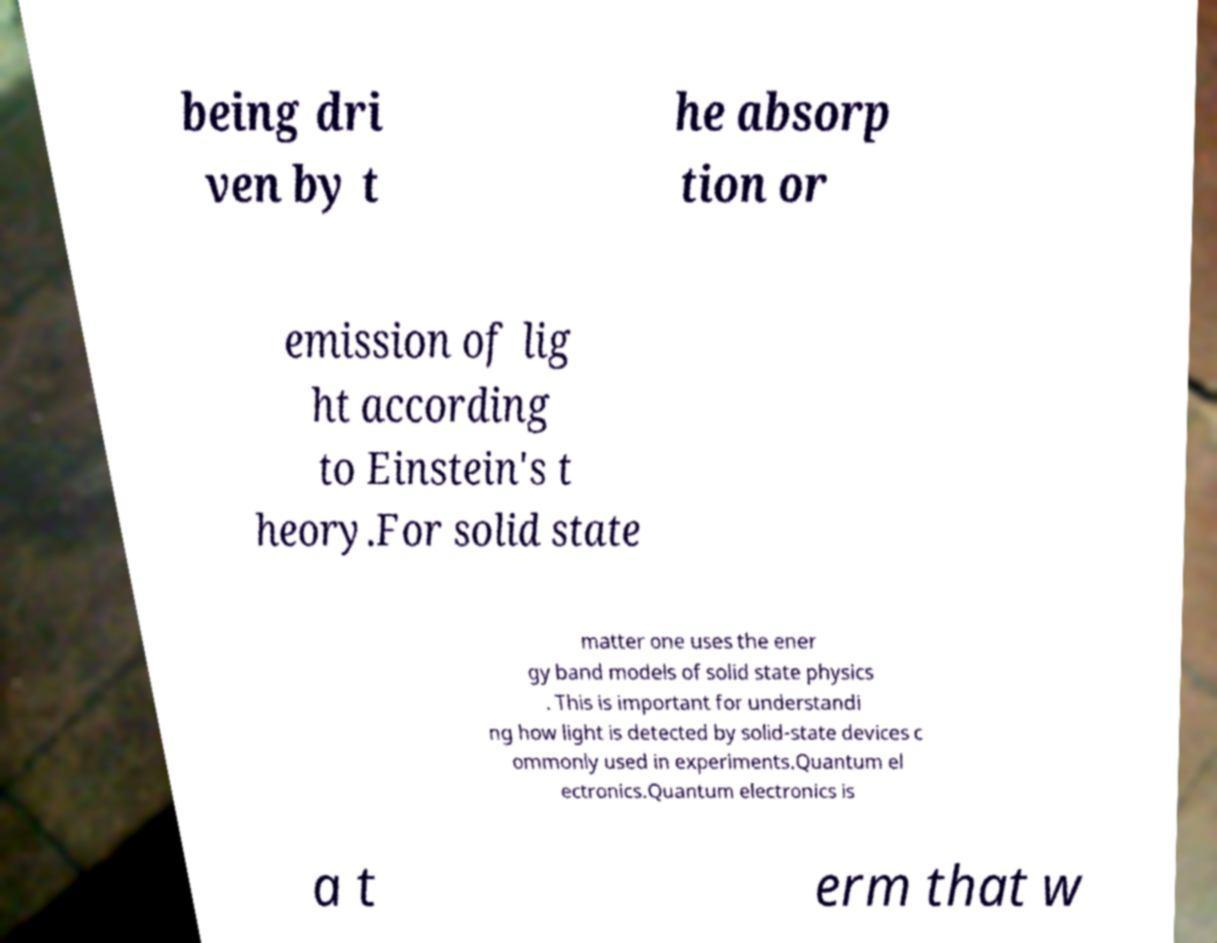I need the written content from this picture converted into text. Can you do that? being dri ven by t he absorp tion or emission of lig ht according to Einstein's t heory.For solid state matter one uses the ener gy band models of solid state physics . This is important for understandi ng how light is detected by solid-state devices c ommonly used in experiments.Quantum el ectronics.Quantum electronics is a t erm that w 